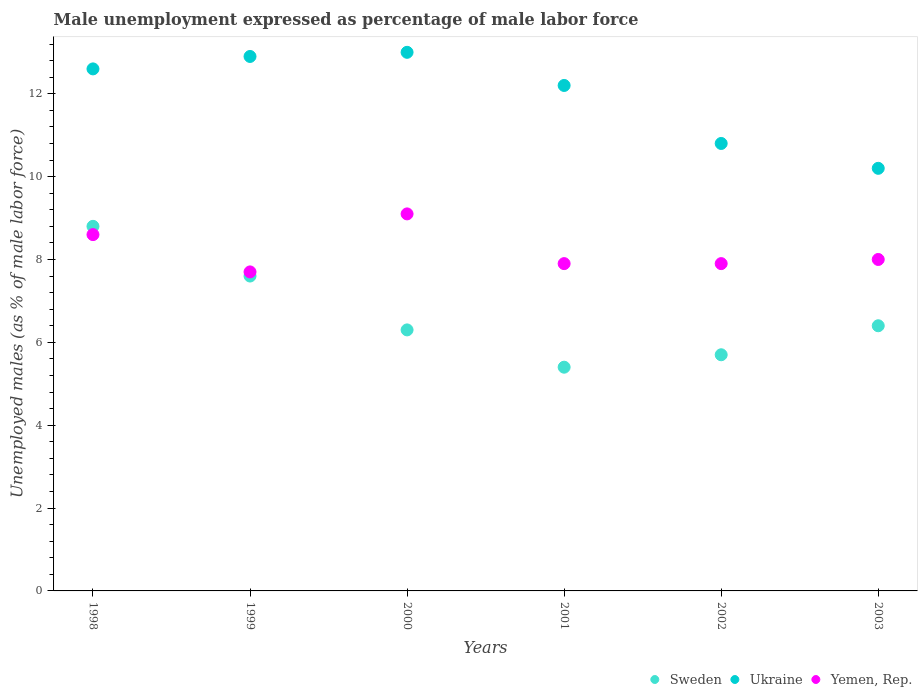How many different coloured dotlines are there?
Make the answer very short. 3. What is the unemployment in males in in Ukraine in 2000?
Give a very brief answer. 13. Across all years, what is the maximum unemployment in males in in Ukraine?
Provide a short and direct response. 13. Across all years, what is the minimum unemployment in males in in Ukraine?
Your answer should be compact. 10.2. In which year was the unemployment in males in in Ukraine maximum?
Provide a short and direct response. 2000. What is the total unemployment in males in in Sweden in the graph?
Provide a short and direct response. 40.2. What is the difference between the unemployment in males in in Yemen, Rep. in 2001 and that in 2003?
Make the answer very short. -0.1. What is the difference between the unemployment in males in in Yemen, Rep. in 1998 and the unemployment in males in in Ukraine in 2001?
Give a very brief answer. -3.6. What is the average unemployment in males in in Yemen, Rep. per year?
Ensure brevity in your answer.  8.2. In the year 2001, what is the difference between the unemployment in males in in Yemen, Rep. and unemployment in males in in Ukraine?
Ensure brevity in your answer.  -4.3. What is the ratio of the unemployment in males in in Sweden in 1999 to that in 2001?
Keep it short and to the point. 1.41. Is the difference between the unemployment in males in in Yemen, Rep. in 1998 and 2001 greater than the difference between the unemployment in males in in Ukraine in 1998 and 2001?
Your answer should be very brief. Yes. What is the difference between the highest and the second highest unemployment in males in in Sweden?
Keep it short and to the point. 1.2. What is the difference between the highest and the lowest unemployment in males in in Sweden?
Give a very brief answer. 3.4. In how many years, is the unemployment in males in in Ukraine greater than the average unemployment in males in in Ukraine taken over all years?
Your response must be concise. 4. Is it the case that in every year, the sum of the unemployment in males in in Ukraine and unemployment in males in in Yemen, Rep.  is greater than the unemployment in males in in Sweden?
Your answer should be very brief. Yes. Does the unemployment in males in in Sweden monotonically increase over the years?
Ensure brevity in your answer.  No. Is the unemployment in males in in Ukraine strictly greater than the unemployment in males in in Sweden over the years?
Your answer should be very brief. Yes. How many years are there in the graph?
Your answer should be compact. 6. Does the graph contain any zero values?
Provide a short and direct response. No. Does the graph contain grids?
Offer a terse response. No. Where does the legend appear in the graph?
Your answer should be compact. Bottom right. How are the legend labels stacked?
Make the answer very short. Horizontal. What is the title of the graph?
Keep it short and to the point. Male unemployment expressed as percentage of male labor force. Does "Cote d'Ivoire" appear as one of the legend labels in the graph?
Offer a very short reply. No. What is the label or title of the X-axis?
Your answer should be very brief. Years. What is the label or title of the Y-axis?
Your response must be concise. Unemployed males (as % of male labor force). What is the Unemployed males (as % of male labor force) in Sweden in 1998?
Your answer should be compact. 8.8. What is the Unemployed males (as % of male labor force) in Ukraine in 1998?
Ensure brevity in your answer.  12.6. What is the Unemployed males (as % of male labor force) in Yemen, Rep. in 1998?
Keep it short and to the point. 8.6. What is the Unemployed males (as % of male labor force) in Sweden in 1999?
Provide a short and direct response. 7.6. What is the Unemployed males (as % of male labor force) in Ukraine in 1999?
Your response must be concise. 12.9. What is the Unemployed males (as % of male labor force) of Yemen, Rep. in 1999?
Keep it short and to the point. 7.7. What is the Unemployed males (as % of male labor force) in Sweden in 2000?
Ensure brevity in your answer.  6.3. What is the Unemployed males (as % of male labor force) of Ukraine in 2000?
Offer a terse response. 13. What is the Unemployed males (as % of male labor force) in Yemen, Rep. in 2000?
Give a very brief answer. 9.1. What is the Unemployed males (as % of male labor force) of Sweden in 2001?
Your answer should be compact. 5.4. What is the Unemployed males (as % of male labor force) of Ukraine in 2001?
Ensure brevity in your answer.  12.2. What is the Unemployed males (as % of male labor force) of Yemen, Rep. in 2001?
Offer a very short reply. 7.9. What is the Unemployed males (as % of male labor force) of Sweden in 2002?
Make the answer very short. 5.7. What is the Unemployed males (as % of male labor force) of Ukraine in 2002?
Provide a short and direct response. 10.8. What is the Unemployed males (as % of male labor force) in Yemen, Rep. in 2002?
Offer a very short reply. 7.9. What is the Unemployed males (as % of male labor force) of Sweden in 2003?
Keep it short and to the point. 6.4. What is the Unemployed males (as % of male labor force) in Ukraine in 2003?
Provide a succinct answer. 10.2. Across all years, what is the maximum Unemployed males (as % of male labor force) of Sweden?
Make the answer very short. 8.8. Across all years, what is the maximum Unemployed males (as % of male labor force) of Yemen, Rep.?
Your response must be concise. 9.1. Across all years, what is the minimum Unemployed males (as % of male labor force) in Sweden?
Offer a very short reply. 5.4. Across all years, what is the minimum Unemployed males (as % of male labor force) of Ukraine?
Your answer should be compact. 10.2. Across all years, what is the minimum Unemployed males (as % of male labor force) of Yemen, Rep.?
Your answer should be compact. 7.7. What is the total Unemployed males (as % of male labor force) of Sweden in the graph?
Your answer should be compact. 40.2. What is the total Unemployed males (as % of male labor force) of Ukraine in the graph?
Offer a terse response. 71.7. What is the total Unemployed males (as % of male labor force) in Yemen, Rep. in the graph?
Provide a succinct answer. 49.2. What is the difference between the Unemployed males (as % of male labor force) in Sweden in 1998 and that in 1999?
Provide a succinct answer. 1.2. What is the difference between the Unemployed males (as % of male labor force) in Sweden in 1998 and that in 2000?
Your answer should be very brief. 2.5. What is the difference between the Unemployed males (as % of male labor force) of Ukraine in 1998 and that in 2000?
Your response must be concise. -0.4. What is the difference between the Unemployed males (as % of male labor force) of Yemen, Rep. in 1998 and that in 2000?
Provide a short and direct response. -0.5. What is the difference between the Unemployed males (as % of male labor force) in Yemen, Rep. in 1998 and that in 2001?
Your answer should be very brief. 0.7. What is the difference between the Unemployed males (as % of male labor force) of Ukraine in 1998 and that in 2002?
Offer a terse response. 1.8. What is the difference between the Unemployed males (as % of male labor force) in Yemen, Rep. in 1998 and that in 2002?
Ensure brevity in your answer.  0.7. What is the difference between the Unemployed males (as % of male labor force) of Yemen, Rep. in 1998 and that in 2003?
Offer a very short reply. 0.6. What is the difference between the Unemployed males (as % of male labor force) of Yemen, Rep. in 1999 and that in 2000?
Offer a terse response. -1.4. What is the difference between the Unemployed males (as % of male labor force) of Ukraine in 1999 and that in 2001?
Your answer should be compact. 0.7. What is the difference between the Unemployed males (as % of male labor force) in Yemen, Rep. in 1999 and that in 2001?
Your answer should be very brief. -0.2. What is the difference between the Unemployed males (as % of male labor force) of Sweden in 1999 and that in 2002?
Provide a succinct answer. 1.9. What is the difference between the Unemployed males (as % of male labor force) in Ukraine in 1999 and that in 2002?
Provide a short and direct response. 2.1. What is the difference between the Unemployed males (as % of male labor force) of Sweden in 2000 and that in 2001?
Offer a terse response. 0.9. What is the difference between the Unemployed males (as % of male labor force) of Ukraine in 2000 and that in 2003?
Your response must be concise. 2.8. What is the difference between the Unemployed males (as % of male labor force) of Yemen, Rep. in 2000 and that in 2003?
Your answer should be compact. 1.1. What is the difference between the Unemployed males (as % of male labor force) in Sweden in 2001 and that in 2002?
Your response must be concise. -0.3. What is the difference between the Unemployed males (as % of male labor force) in Ukraine in 2001 and that in 2003?
Offer a very short reply. 2. What is the difference between the Unemployed males (as % of male labor force) of Sweden in 2002 and that in 2003?
Offer a very short reply. -0.7. What is the difference between the Unemployed males (as % of male labor force) in Ukraine in 2002 and that in 2003?
Make the answer very short. 0.6. What is the difference between the Unemployed males (as % of male labor force) of Sweden in 1998 and the Unemployed males (as % of male labor force) of Ukraine in 1999?
Offer a very short reply. -4.1. What is the difference between the Unemployed males (as % of male labor force) of Sweden in 1998 and the Unemployed males (as % of male labor force) of Yemen, Rep. in 1999?
Offer a terse response. 1.1. What is the difference between the Unemployed males (as % of male labor force) in Ukraine in 1998 and the Unemployed males (as % of male labor force) in Yemen, Rep. in 1999?
Provide a succinct answer. 4.9. What is the difference between the Unemployed males (as % of male labor force) of Sweden in 1998 and the Unemployed males (as % of male labor force) of Yemen, Rep. in 2000?
Make the answer very short. -0.3. What is the difference between the Unemployed males (as % of male labor force) in Sweden in 1998 and the Unemployed males (as % of male labor force) in Yemen, Rep. in 2001?
Give a very brief answer. 0.9. What is the difference between the Unemployed males (as % of male labor force) in Ukraine in 1998 and the Unemployed males (as % of male labor force) in Yemen, Rep. in 2001?
Offer a terse response. 4.7. What is the difference between the Unemployed males (as % of male labor force) in Sweden in 1998 and the Unemployed males (as % of male labor force) in Yemen, Rep. in 2003?
Provide a short and direct response. 0.8. What is the difference between the Unemployed males (as % of male labor force) in Ukraine in 1999 and the Unemployed males (as % of male labor force) in Yemen, Rep. in 2001?
Offer a very short reply. 5. What is the difference between the Unemployed males (as % of male labor force) in Ukraine in 1999 and the Unemployed males (as % of male labor force) in Yemen, Rep. in 2002?
Offer a terse response. 5. What is the difference between the Unemployed males (as % of male labor force) of Sweden in 1999 and the Unemployed males (as % of male labor force) of Ukraine in 2003?
Provide a short and direct response. -2.6. What is the difference between the Unemployed males (as % of male labor force) in Sweden in 1999 and the Unemployed males (as % of male labor force) in Yemen, Rep. in 2003?
Make the answer very short. -0.4. What is the difference between the Unemployed males (as % of male labor force) of Sweden in 2000 and the Unemployed males (as % of male labor force) of Ukraine in 2002?
Your answer should be very brief. -4.5. What is the difference between the Unemployed males (as % of male labor force) of Ukraine in 2000 and the Unemployed males (as % of male labor force) of Yemen, Rep. in 2002?
Keep it short and to the point. 5.1. What is the difference between the Unemployed males (as % of male labor force) in Ukraine in 2000 and the Unemployed males (as % of male labor force) in Yemen, Rep. in 2003?
Keep it short and to the point. 5. What is the difference between the Unemployed males (as % of male labor force) in Sweden in 2002 and the Unemployed males (as % of male labor force) in Ukraine in 2003?
Provide a short and direct response. -4.5. What is the average Unemployed males (as % of male labor force) of Sweden per year?
Provide a succinct answer. 6.7. What is the average Unemployed males (as % of male labor force) in Ukraine per year?
Your answer should be very brief. 11.95. What is the average Unemployed males (as % of male labor force) of Yemen, Rep. per year?
Make the answer very short. 8.2. In the year 1999, what is the difference between the Unemployed males (as % of male labor force) of Sweden and Unemployed males (as % of male labor force) of Ukraine?
Offer a very short reply. -5.3. In the year 1999, what is the difference between the Unemployed males (as % of male labor force) of Sweden and Unemployed males (as % of male labor force) of Yemen, Rep.?
Your answer should be very brief. -0.1. In the year 2000, what is the difference between the Unemployed males (as % of male labor force) in Sweden and Unemployed males (as % of male labor force) in Yemen, Rep.?
Offer a terse response. -2.8. In the year 2001, what is the difference between the Unemployed males (as % of male labor force) in Ukraine and Unemployed males (as % of male labor force) in Yemen, Rep.?
Offer a very short reply. 4.3. In the year 2002, what is the difference between the Unemployed males (as % of male labor force) in Sweden and Unemployed males (as % of male labor force) in Ukraine?
Make the answer very short. -5.1. In the year 2002, what is the difference between the Unemployed males (as % of male labor force) in Sweden and Unemployed males (as % of male labor force) in Yemen, Rep.?
Your answer should be compact. -2.2. In the year 2003, what is the difference between the Unemployed males (as % of male labor force) of Sweden and Unemployed males (as % of male labor force) of Ukraine?
Your answer should be very brief. -3.8. In the year 2003, what is the difference between the Unemployed males (as % of male labor force) of Sweden and Unemployed males (as % of male labor force) of Yemen, Rep.?
Provide a short and direct response. -1.6. In the year 2003, what is the difference between the Unemployed males (as % of male labor force) in Ukraine and Unemployed males (as % of male labor force) in Yemen, Rep.?
Your answer should be compact. 2.2. What is the ratio of the Unemployed males (as % of male labor force) of Sweden in 1998 to that in 1999?
Your answer should be very brief. 1.16. What is the ratio of the Unemployed males (as % of male labor force) in Ukraine in 1998 to that in 1999?
Provide a succinct answer. 0.98. What is the ratio of the Unemployed males (as % of male labor force) in Yemen, Rep. in 1998 to that in 1999?
Offer a terse response. 1.12. What is the ratio of the Unemployed males (as % of male labor force) in Sweden in 1998 to that in 2000?
Offer a very short reply. 1.4. What is the ratio of the Unemployed males (as % of male labor force) in Ukraine in 1998 to that in 2000?
Keep it short and to the point. 0.97. What is the ratio of the Unemployed males (as % of male labor force) in Yemen, Rep. in 1998 to that in 2000?
Make the answer very short. 0.95. What is the ratio of the Unemployed males (as % of male labor force) in Sweden in 1998 to that in 2001?
Offer a very short reply. 1.63. What is the ratio of the Unemployed males (as % of male labor force) in Ukraine in 1998 to that in 2001?
Your answer should be compact. 1.03. What is the ratio of the Unemployed males (as % of male labor force) in Yemen, Rep. in 1998 to that in 2001?
Give a very brief answer. 1.09. What is the ratio of the Unemployed males (as % of male labor force) of Sweden in 1998 to that in 2002?
Provide a succinct answer. 1.54. What is the ratio of the Unemployed males (as % of male labor force) in Ukraine in 1998 to that in 2002?
Give a very brief answer. 1.17. What is the ratio of the Unemployed males (as % of male labor force) in Yemen, Rep. in 1998 to that in 2002?
Your answer should be very brief. 1.09. What is the ratio of the Unemployed males (as % of male labor force) of Sweden in 1998 to that in 2003?
Offer a terse response. 1.38. What is the ratio of the Unemployed males (as % of male labor force) in Ukraine in 1998 to that in 2003?
Your response must be concise. 1.24. What is the ratio of the Unemployed males (as % of male labor force) of Yemen, Rep. in 1998 to that in 2003?
Provide a succinct answer. 1.07. What is the ratio of the Unemployed males (as % of male labor force) of Sweden in 1999 to that in 2000?
Your answer should be compact. 1.21. What is the ratio of the Unemployed males (as % of male labor force) of Ukraine in 1999 to that in 2000?
Provide a short and direct response. 0.99. What is the ratio of the Unemployed males (as % of male labor force) of Yemen, Rep. in 1999 to that in 2000?
Your answer should be very brief. 0.85. What is the ratio of the Unemployed males (as % of male labor force) of Sweden in 1999 to that in 2001?
Your answer should be compact. 1.41. What is the ratio of the Unemployed males (as % of male labor force) in Ukraine in 1999 to that in 2001?
Keep it short and to the point. 1.06. What is the ratio of the Unemployed males (as % of male labor force) in Yemen, Rep. in 1999 to that in 2001?
Make the answer very short. 0.97. What is the ratio of the Unemployed males (as % of male labor force) in Sweden in 1999 to that in 2002?
Ensure brevity in your answer.  1.33. What is the ratio of the Unemployed males (as % of male labor force) of Ukraine in 1999 to that in 2002?
Your answer should be very brief. 1.19. What is the ratio of the Unemployed males (as % of male labor force) in Yemen, Rep. in 1999 to that in 2002?
Give a very brief answer. 0.97. What is the ratio of the Unemployed males (as % of male labor force) of Sweden in 1999 to that in 2003?
Keep it short and to the point. 1.19. What is the ratio of the Unemployed males (as % of male labor force) of Ukraine in 1999 to that in 2003?
Provide a succinct answer. 1.26. What is the ratio of the Unemployed males (as % of male labor force) in Yemen, Rep. in 1999 to that in 2003?
Make the answer very short. 0.96. What is the ratio of the Unemployed males (as % of male labor force) in Ukraine in 2000 to that in 2001?
Offer a terse response. 1.07. What is the ratio of the Unemployed males (as % of male labor force) in Yemen, Rep. in 2000 to that in 2001?
Keep it short and to the point. 1.15. What is the ratio of the Unemployed males (as % of male labor force) of Sweden in 2000 to that in 2002?
Keep it short and to the point. 1.11. What is the ratio of the Unemployed males (as % of male labor force) of Ukraine in 2000 to that in 2002?
Make the answer very short. 1.2. What is the ratio of the Unemployed males (as % of male labor force) of Yemen, Rep. in 2000 to that in 2002?
Make the answer very short. 1.15. What is the ratio of the Unemployed males (as % of male labor force) of Sweden in 2000 to that in 2003?
Provide a succinct answer. 0.98. What is the ratio of the Unemployed males (as % of male labor force) in Ukraine in 2000 to that in 2003?
Your response must be concise. 1.27. What is the ratio of the Unemployed males (as % of male labor force) in Yemen, Rep. in 2000 to that in 2003?
Keep it short and to the point. 1.14. What is the ratio of the Unemployed males (as % of male labor force) of Ukraine in 2001 to that in 2002?
Your response must be concise. 1.13. What is the ratio of the Unemployed males (as % of male labor force) of Sweden in 2001 to that in 2003?
Offer a terse response. 0.84. What is the ratio of the Unemployed males (as % of male labor force) in Ukraine in 2001 to that in 2003?
Give a very brief answer. 1.2. What is the ratio of the Unemployed males (as % of male labor force) of Yemen, Rep. in 2001 to that in 2003?
Offer a terse response. 0.99. What is the ratio of the Unemployed males (as % of male labor force) in Sweden in 2002 to that in 2003?
Make the answer very short. 0.89. What is the ratio of the Unemployed males (as % of male labor force) of Ukraine in 2002 to that in 2003?
Make the answer very short. 1.06. What is the ratio of the Unemployed males (as % of male labor force) in Yemen, Rep. in 2002 to that in 2003?
Your response must be concise. 0.99. What is the difference between the highest and the lowest Unemployed males (as % of male labor force) of Ukraine?
Your answer should be very brief. 2.8. What is the difference between the highest and the lowest Unemployed males (as % of male labor force) of Yemen, Rep.?
Offer a very short reply. 1.4. 